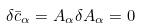Convert formula to latex. <formula><loc_0><loc_0><loc_500><loc_500>\delta \bar { c } _ { \alpha } = A _ { \alpha } \delta A _ { \alpha } = 0</formula> 